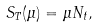Convert formula to latex. <formula><loc_0><loc_0><loc_500><loc_500>S _ { T } ( \mu ) = \mu N _ { t } ,</formula> 